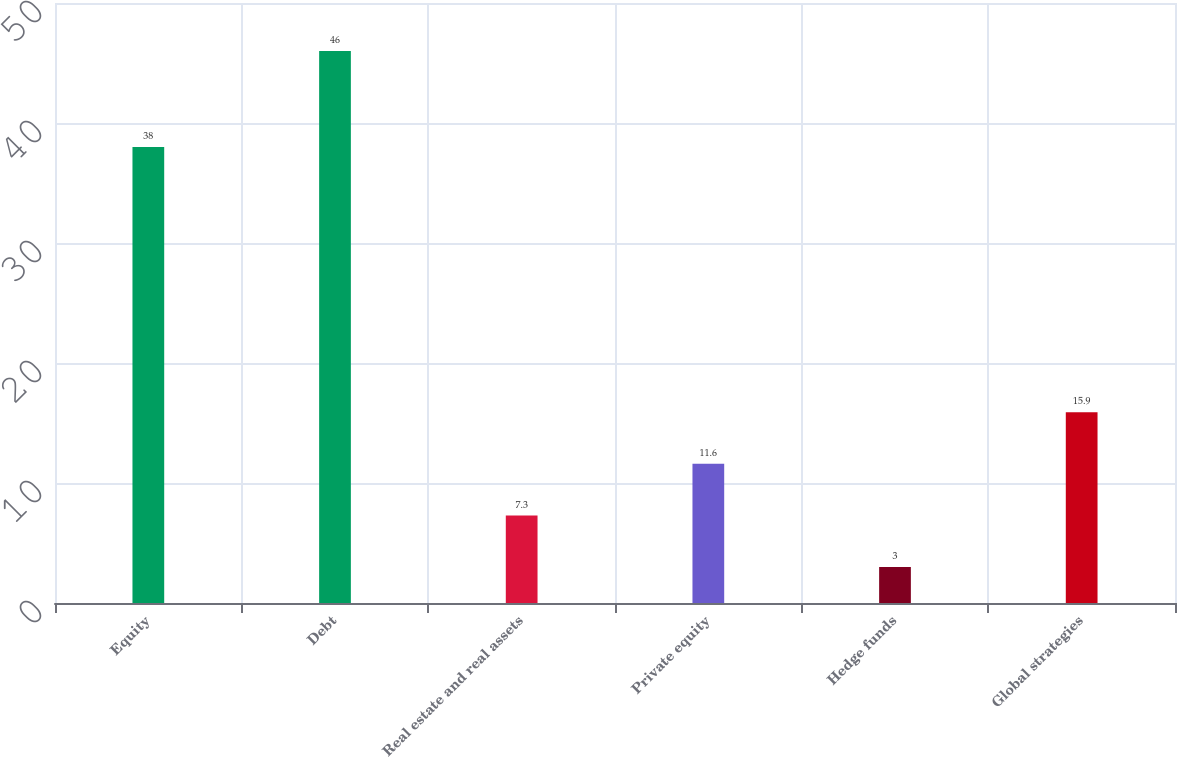Convert chart. <chart><loc_0><loc_0><loc_500><loc_500><bar_chart><fcel>Equity<fcel>Debt<fcel>Real estate and real assets<fcel>Private equity<fcel>Hedge funds<fcel>Global strategies<nl><fcel>38<fcel>46<fcel>7.3<fcel>11.6<fcel>3<fcel>15.9<nl></chart> 